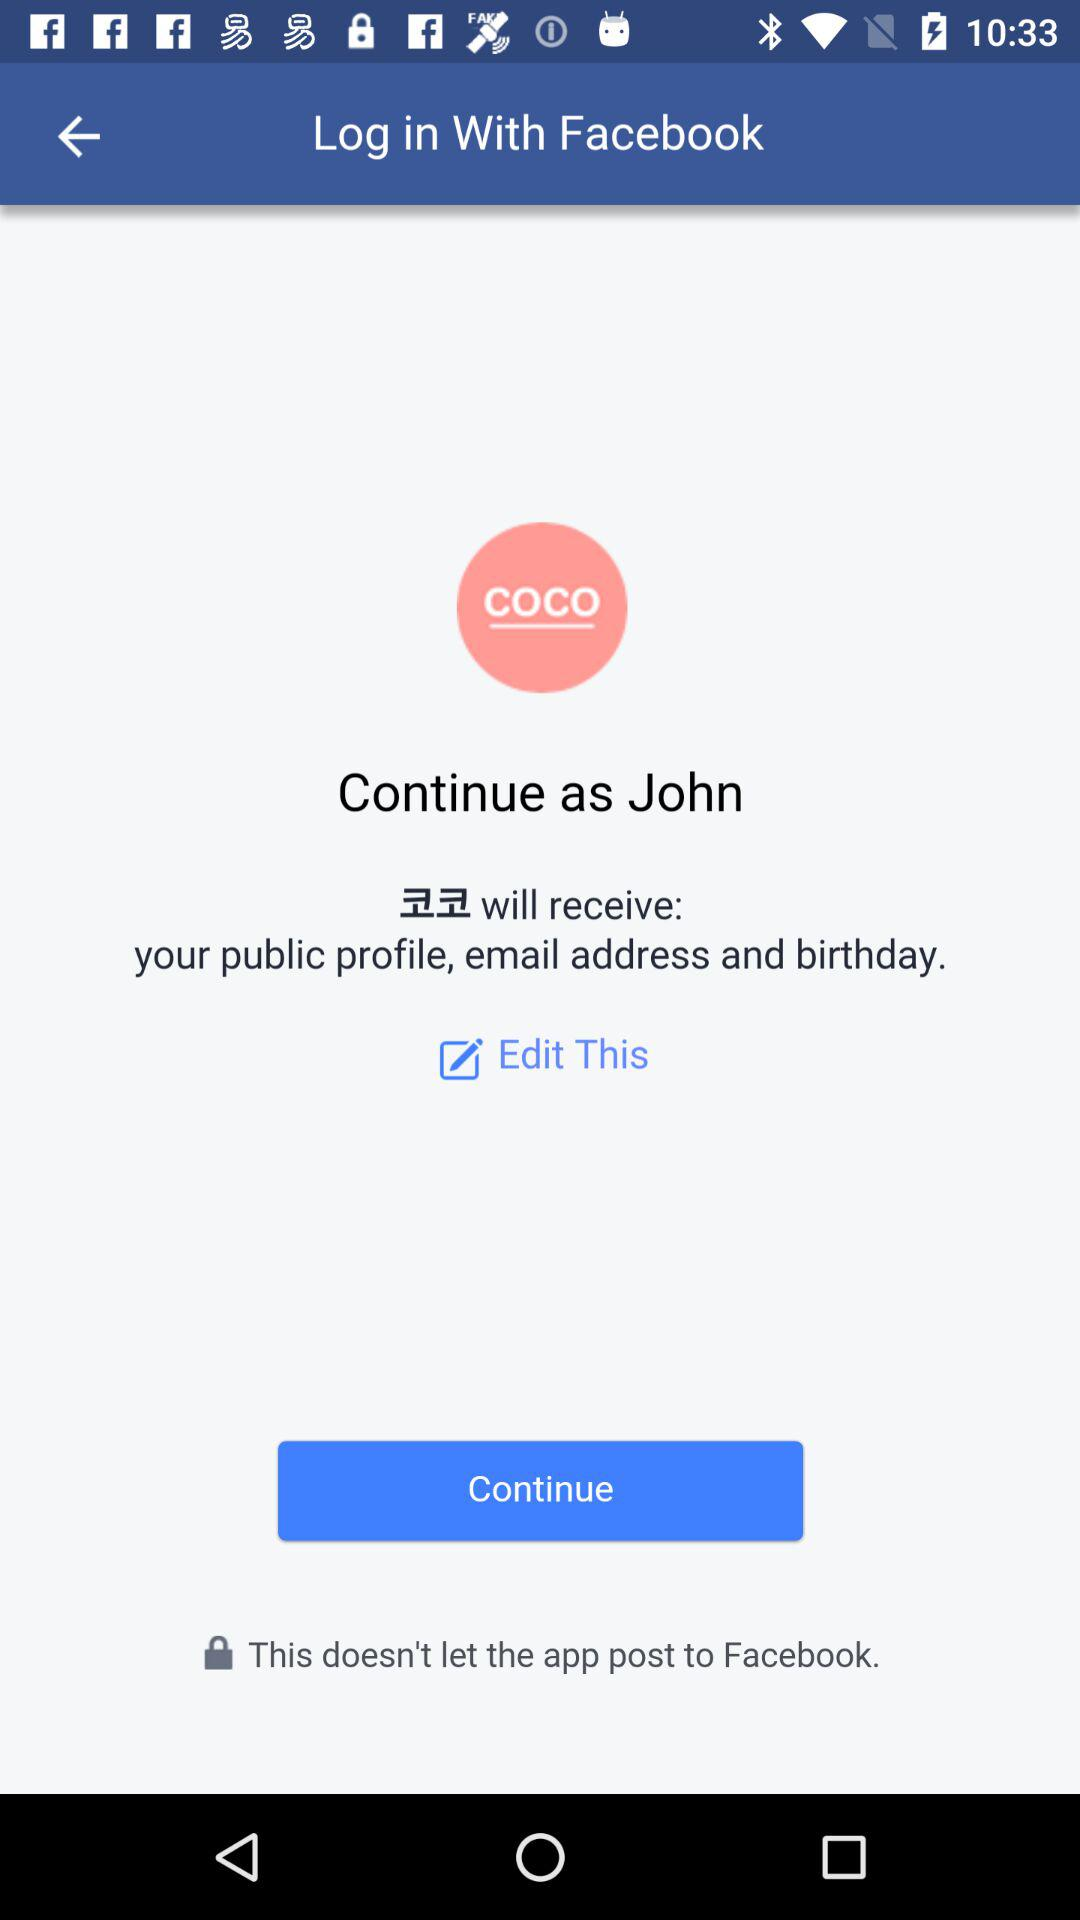How can we login? You can login with Facebook. 